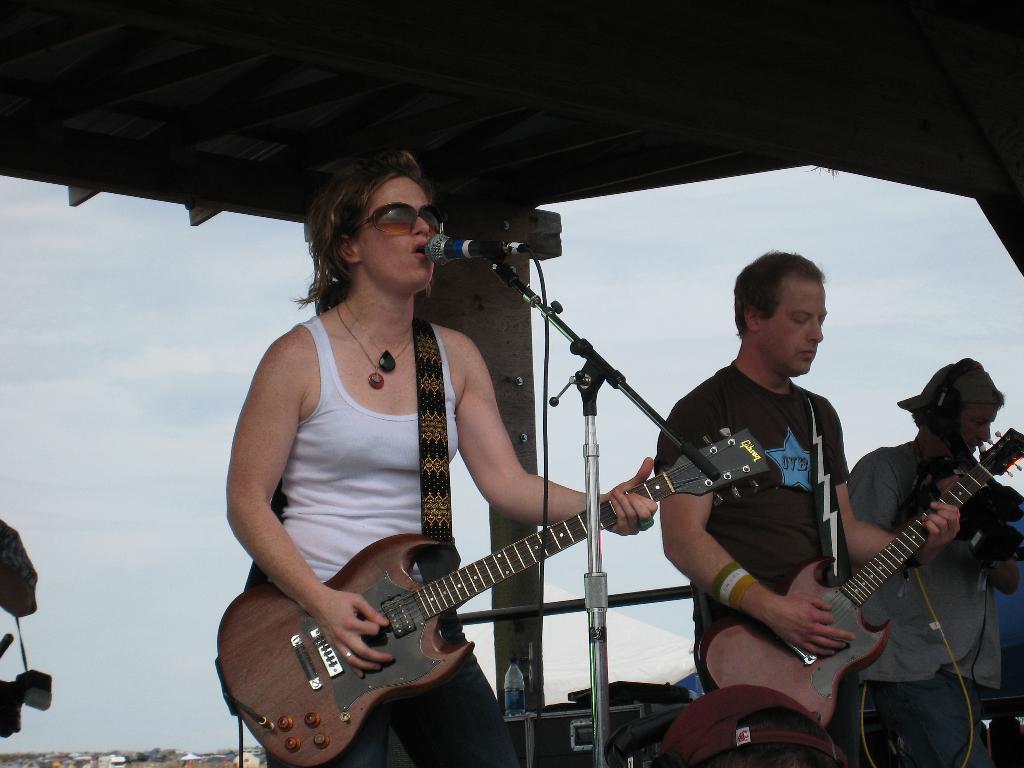Please provide a concise description of this image. In this picture we can see two persons who are playing guitars. She is singing on the mike and she has spectacles. Here we can see a man. On the background there is a sky. 